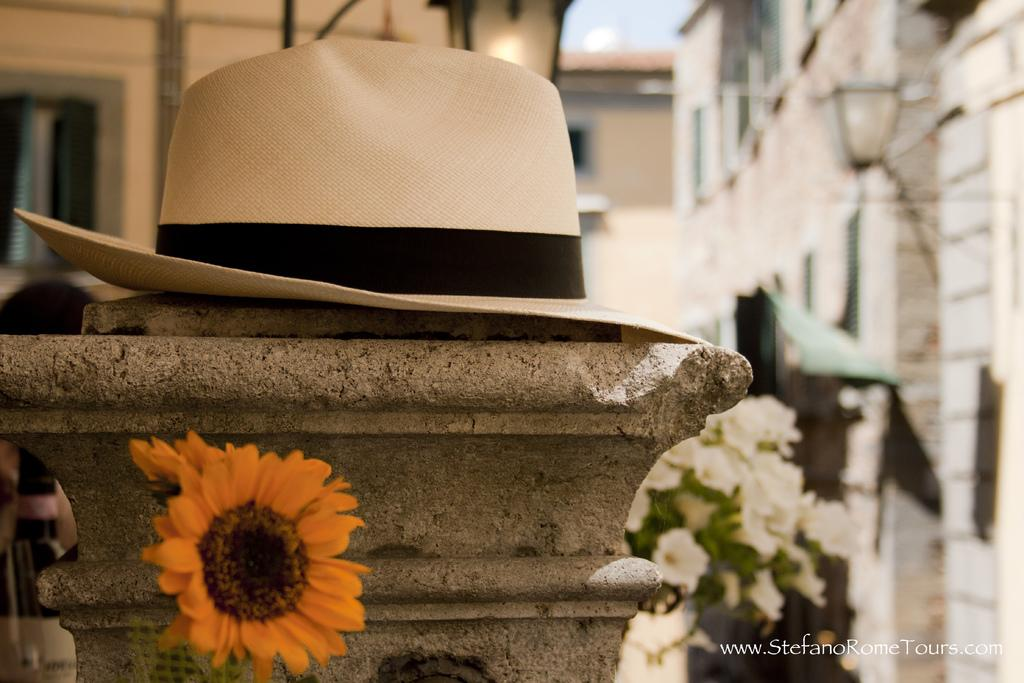What object can be seen in the image that is typically worn on the head? There is a hat in the image. What type of flora is present in the image? There are flowers in the image. Is there any text or logo visible in the image? Yes, there is a watermark in the image. How would you describe the background of the image? The background of the image is blurred. What type of structures can be seen in the distance in the image? There are buildings visible in the background of the image. How much sugar is present in the room depicted in the image? There is no room depicted in the image, and therefore no sugar can be measured or observed. 